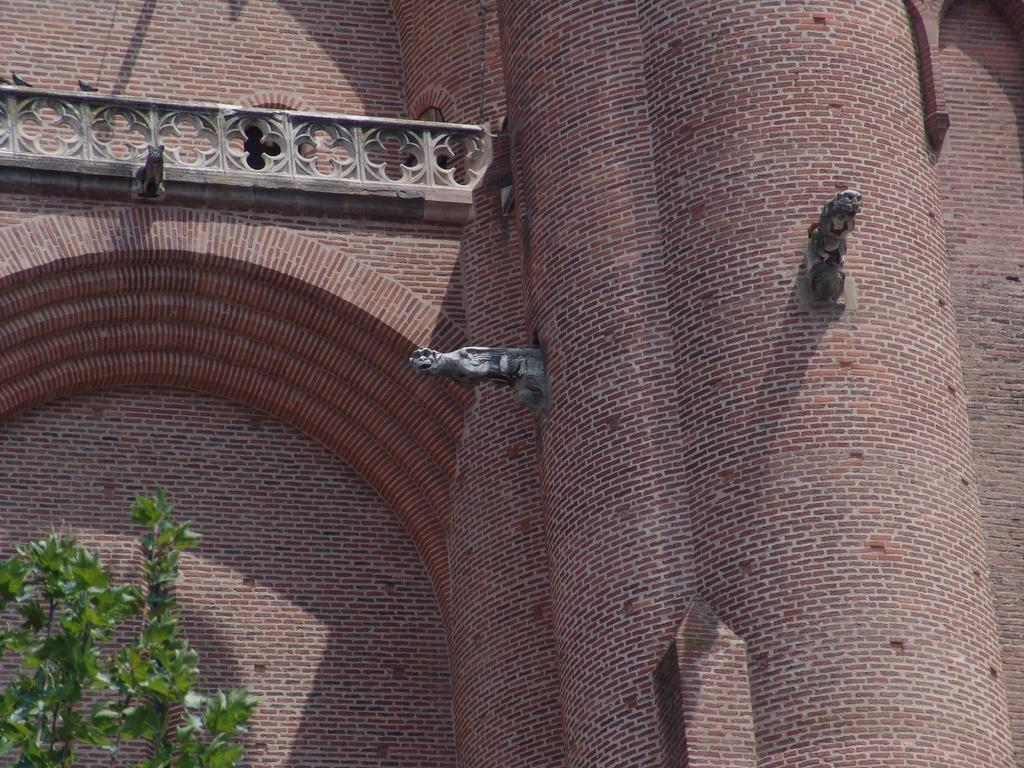What type of structure is present in the image? There is a building in the image. What type of vegetation is present in the image? There is a tree in the image. How many deer can be seen grazing near the building in the image? There are no deer present in the image. What type of birds can be seen flying around the tree in the image? There are no birds visible in the image. 